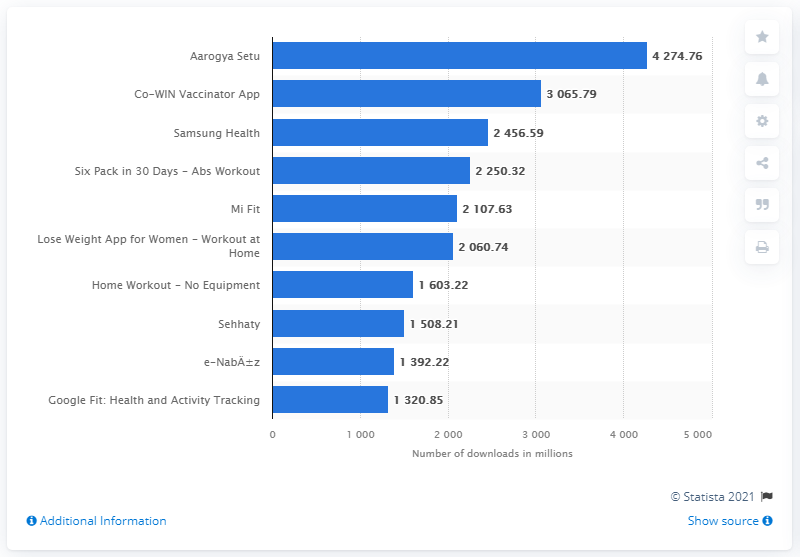Give some essential details in this illustration. The Co-WIN Vaccinator App was the second most popular app in the Google Play Store. 